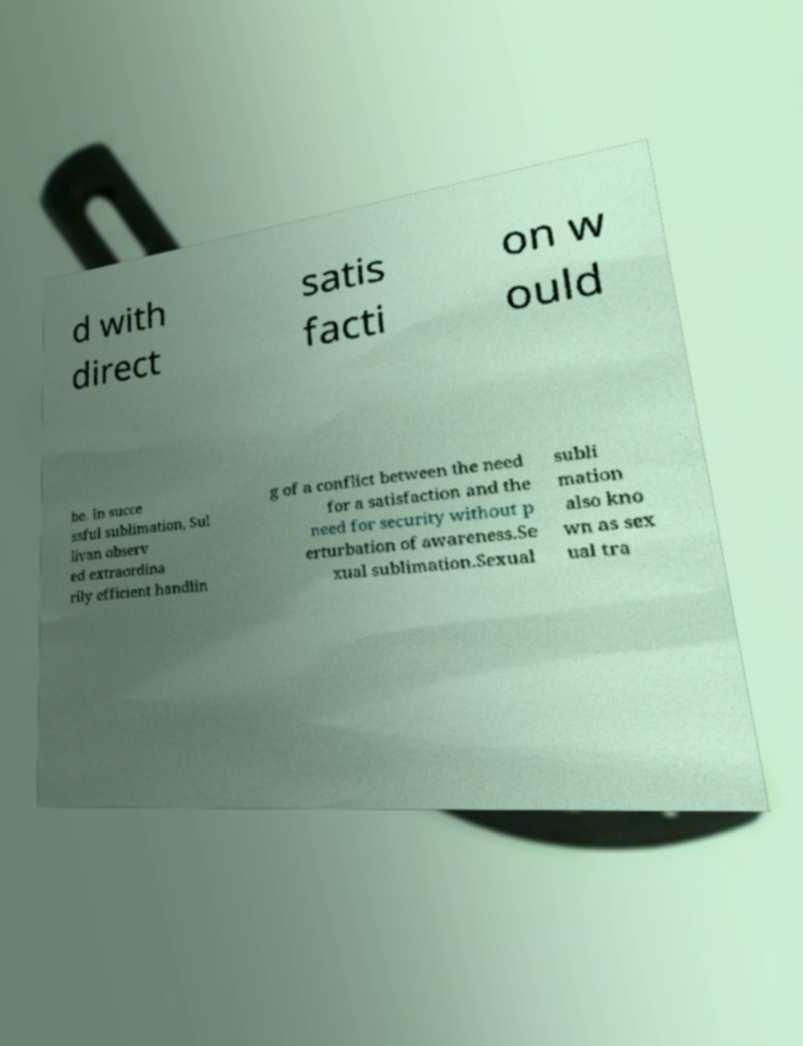Could you assist in decoding the text presented in this image and type it out clearly? d with direct satis facti on w ould be. In succe ssful sublimation, Sul livan observ ed extraordina rily efficient handlin g of a conflict between the need for a satisfaction and the need for security without p erturbation of awareness.Se xual sublimation.Sexual subli mation also kno wn as sex ual tra 